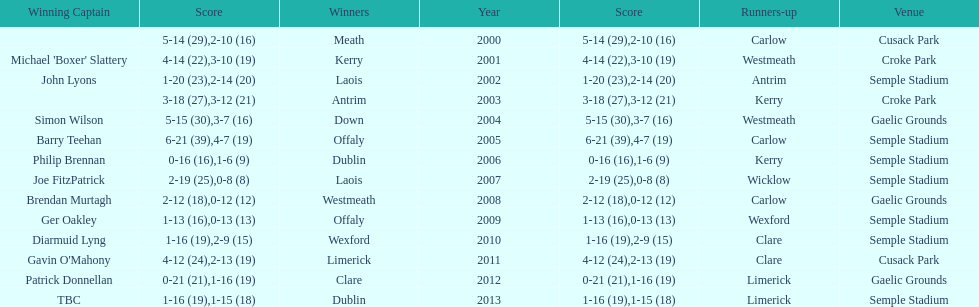Who was the first winner in 2013? Dublin. 